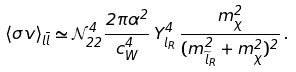<formula> <loc_0><loc_0><loc_500><loc_500>\langle \sigma v \rangle _ { l \overline { l } } \simeq \mathcal { N } _ { 2 2 } ^ { 4 } \frac { 2 \pi \alpha ^ { 2 } } { c _ { W } ^ { 4 } } \, Y _ { l _ { R } } ^ { 4 } \, \frac { m _ { \chi } ^ { 2 } } { ( m _ { \widetilde { l } _ { R } } ^ { 2 } + m _ { \chi } ^ { 2 } ) ^ { 2 } } \, .</formula> 